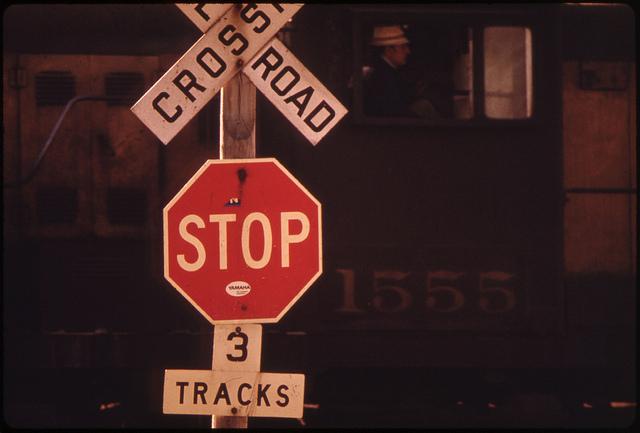How many tracks are there?
Short answer required. 3. Is there damage done to the sign under the stop sign?
Give a very brief answer. No. What is written on the red sign?
Answer briefly. Stop. Is the man on the train wearing a hat?
Concise answer only. Yes. 